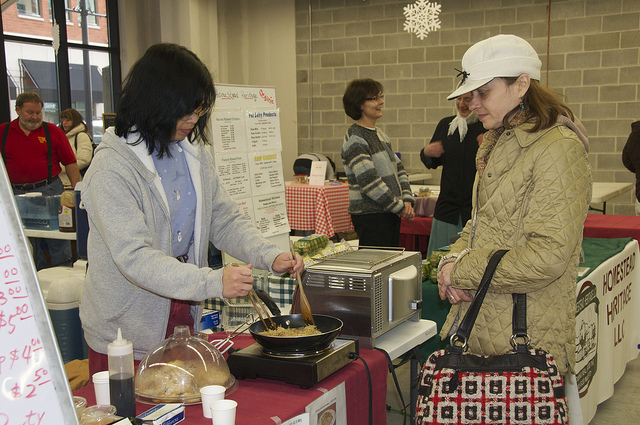<image>What type of music are they playing? I don't know what type of music they are playing. The possibilities include 'asian', 'christmas', 'pop', 'polka', 'easy listening', 'indie', or 'country'. What type of music are they playing? I don't know what type of music they are playing. It could be any of the mentioned genres. 